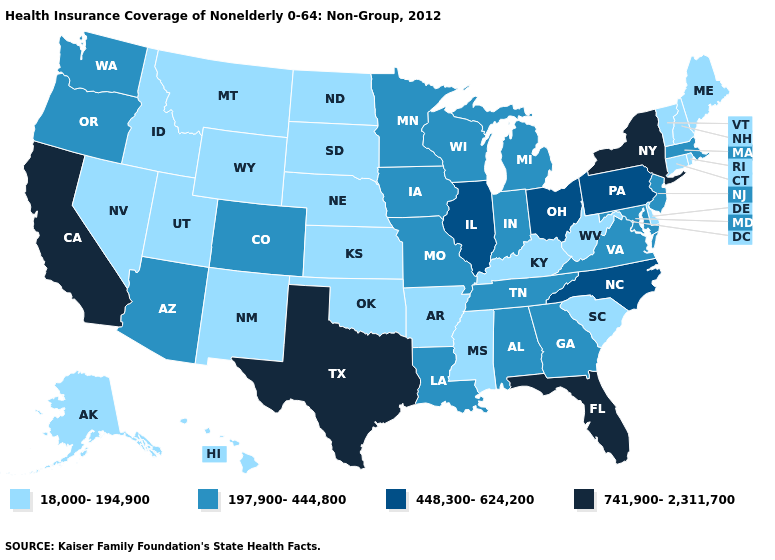Name the states that have a value in the range 448,300-624,200?
Write a very short answer. Illinois, North Carolina, Ohio, Pennsylvania. How many symbols are there in the legend?
Be succinct. 4. What is the value of Idaho?
Keep it brief. 18,000-194,900. Does the map have missing data?
Answer briefly. No. Does Tennessee have the lowest value in the South?
Be succinct. No. Does Indiana have a lower value than Illinois?
Concise answer only. Yes. Among the states that border Utah , does Colorado have the highest value?
Give a very brief answer. Yes. Does Michigan have a lower value than Ohio?
Short answer required. Yes. Does Kansas have the lowest value in the MidWest?
Keep it brief. Yes. Name the states that have a value in the range 18,000-194,900?
Short answer required. Alaska, Arkansas, Connecticut, Delaware, Hawaii, Idaho, Kansas, Kentucky, Maine, Mississippi, Montana, Nebraska, Nevada, New Hampshire, New Mexico, North Dakota, Oklahoma, Rhode Island, South Carolina, South Dakota, Utah, Vermont, West Virginia, Wyoming. What is the lowest value in the USA?
Write a very short answer. 18,000-194,900. What is the lowest value in the USA?
Be succinct. 18,000-194,900. What is the value of Kentucky?
Quick response, please. 18,000-194,900. Name the states that have a value in the range 448,300-624,200?
Keep it brief. Illinois, North Carolina, Ohio, Pennsylvania. What is the highest value in states that border New Jersey?
Be succinct. 741,900-2,311,700. 